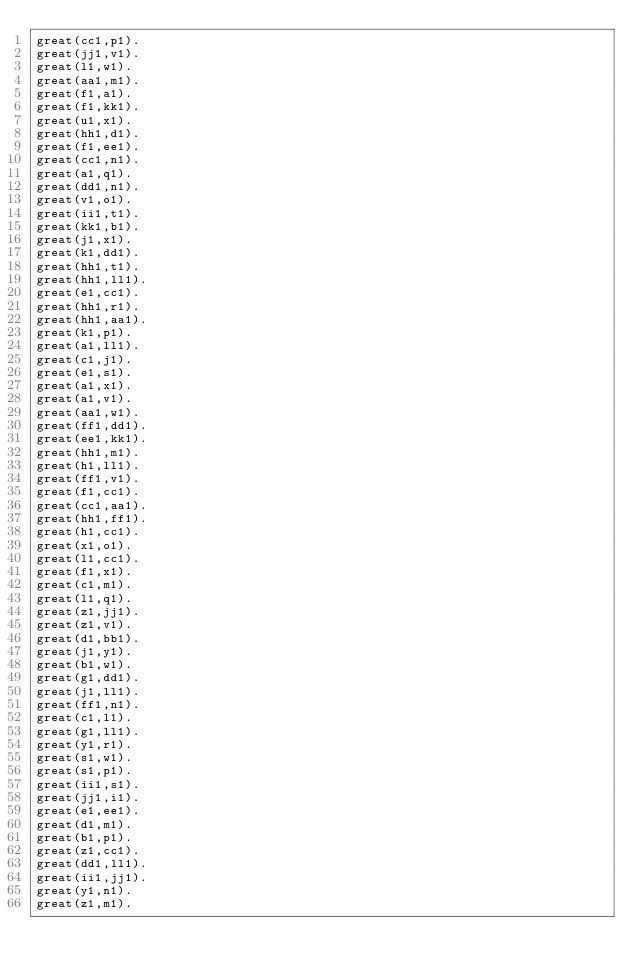Convert code to text. <code><loc_0><loc_0><loc_500><loc_500><_FORTRAN_>great(cc1,p1).
great(jj1,v1).
great(l1,w1).
great(aa1,m1).
great(f1,a1).
great(f1,kk1).
great(u1,x1).
great(hh1,d1).
great(f1,ee1).
great(cc1,n1).
great(a1,q1).
great(dd1,n1).
great(v1,o1).
great(ii1,t1).
great(kk1,b1).
great(j1,x1).
great(k1,dd1).
great(hh1,t1).
great(hh1,ll1).
great(e1,cc1).
great(hh1,r1).
great(hh1,aa1).
great(k1,p1).
great(a1,ll1).
great(c1,j1).
great(e1,s1).
great(a1,x1).
great(a1,v1).
great(aa1,w1).
great(ff1,dd1).
great(ee1,kk1).
great(hh1,m1).
great(h1,ll1).
great(ff1,v1).
great(f1,cc1).
great(cc1,aa1).
great(hh1,ff1).
great(h1,cc1).
great(x1,o1).
great(l1,cc1).
great(f1,x1).
great(c1,m1).
great(l1,q1).
great(z1,jj1).
great(z1,v1).
great(d1,bb1).
great(j1,y1).
great(b1,w1).
great(g1,dd1).
great(j1,ll1).
great(ff1,n1).
great(c1,l1).
great(g1,ll1).
great(y1,r1).
great(s1,w1).
great(s1,p1).
great(ii1,s1).
great(jj1,i1).
great(e1,ee1).
great(d1,m1).
great(b1,p1).
great(z1,cc1).
great(dd1,ll1).
great(ii1,jj1).
great(y1,n1).
great(z1,m1).
</code> 